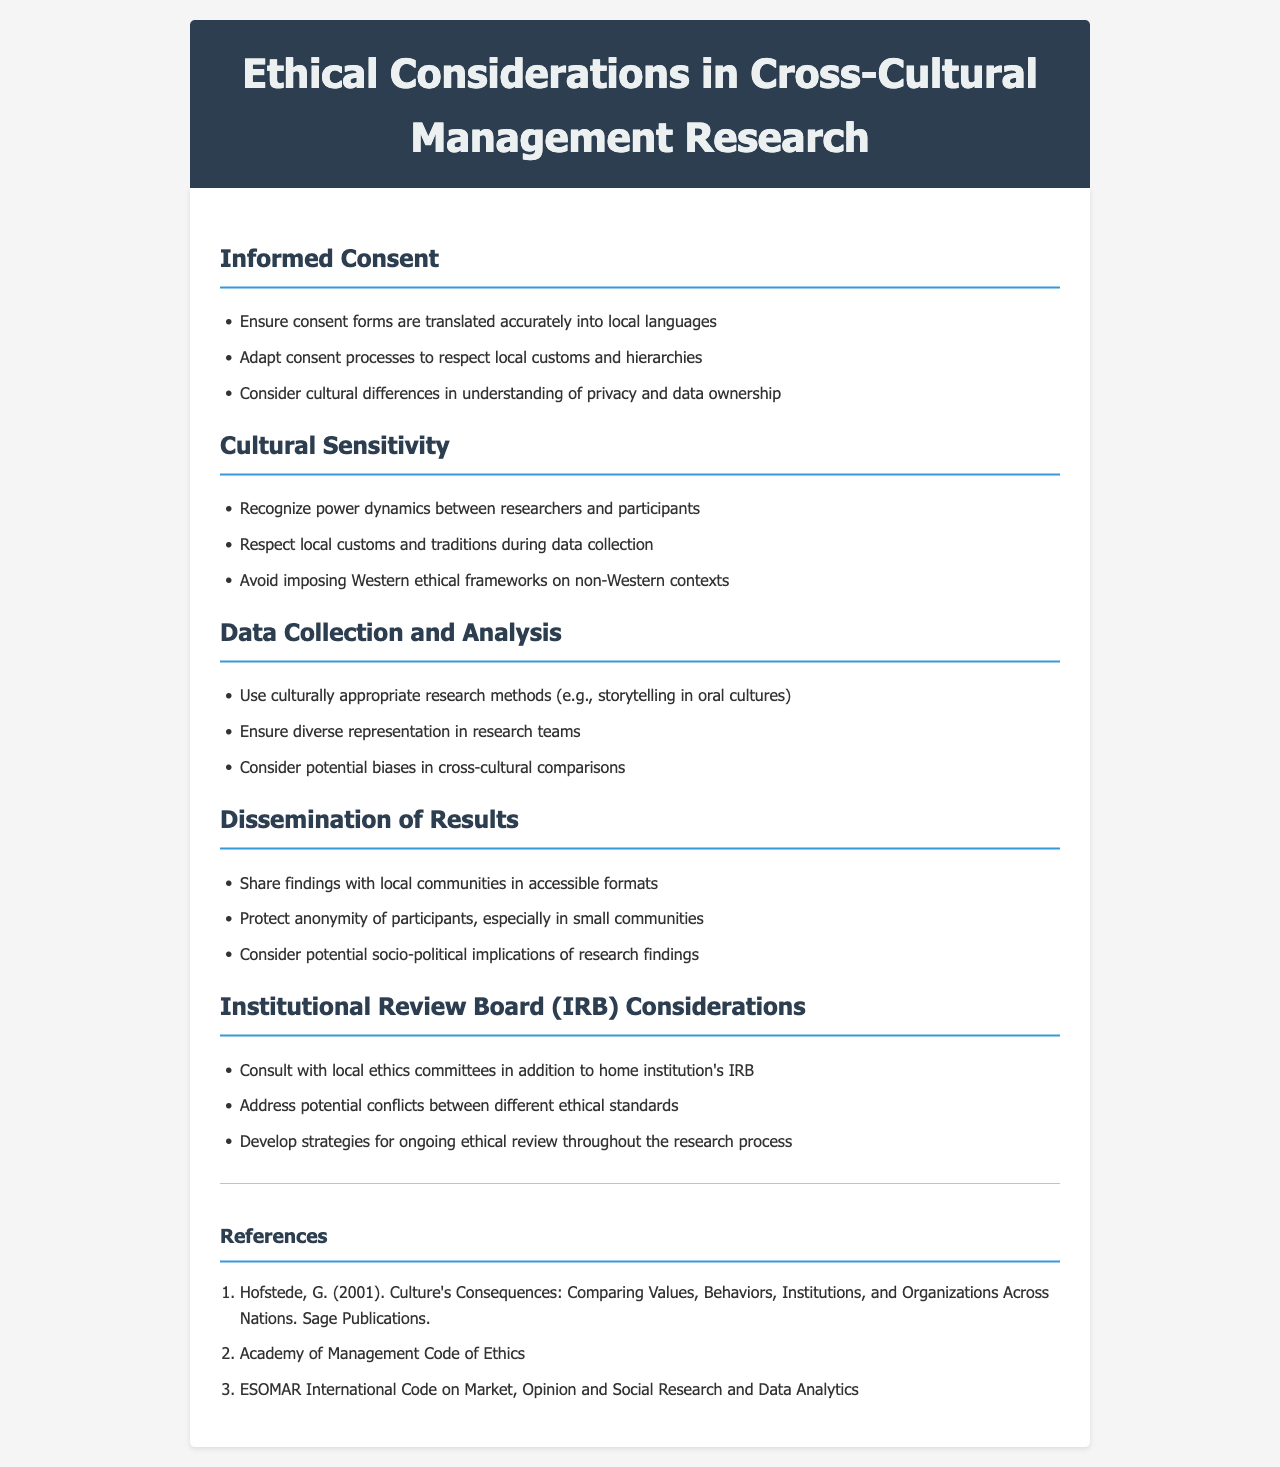what is the title of the document? The title appears in the header section of the document.
Answer: Ethical Considerations in Cross-Cultural Management Research how many sections are in the document? The document is divided into several sections, each focusing on a different ethical consideration.
Answer: 5 what is one of the considerations listed under Informed Consent? The document lists several ethical considerations under the Informed Consent section.
Answer: Ensure consent forms are translated accurately into local languages what should researchers respect during data collection? This question pertains to the Cultural Sensitivity section, which outlines important practices for researchers.
Answer: local customs and traditions who should be consulted alongside the home institution's IRB? This question relates to the Institutional Review Board (IRB) considerations outlined in the document.
Answer: local ethics committees what is a recommended research method for oral cultures? This information is found in the Data Collection and Analysis section, which discusses culturally appropriate methods.
Answer: storytelling which publication discusses values, behaviors, and institutions across nations? This is a reference listed at the end of the document, relating to cross-cultural research.
Answer: Culture's Consequences: Comparing Values, Behaviors, Institutions, and Organizations Across Nations how should findings be shared with local communities? This question relates to the dissemination practices discussed in the document, which emphasizes accessibility.
Answer: in accessible formats 